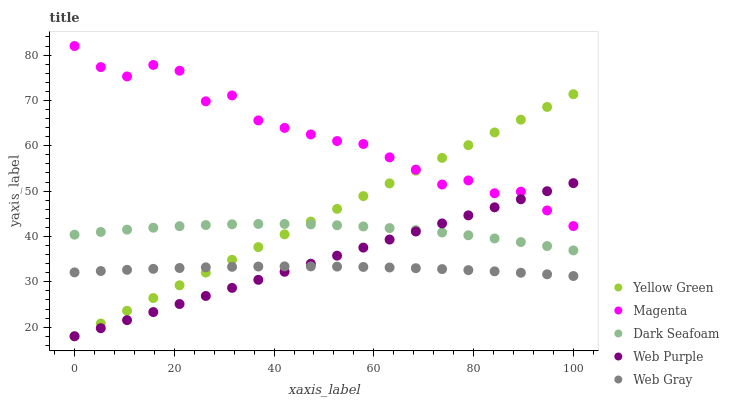Does Web Gray have the minimum area under the curve?
Answer yes or no. Yes. Does Magenta have the maximum area under the curve?
Answer yes or no. Yes. Does Magenta have the minimum area under the curve?
Answer yes or no. No. Does Web Gray have the maximum area under the curve?
Answer yes or no. No. Is Yellow Green the smoothest?
Answer yes or no. Yes. Is Magenta the roughest?
Answer yes or no. Yes. Is Web Gray the smoothest?
Answer yes or no. No. Is Web Gray the roughest?
Answer yes or no. No. Does Web Purple have the lowest value?
Answer yes or no. Yes. Does Web Gray have the lowest value?
Answer yes or no. No. Does Magenta have the highest value?
Answer yes or no. Yes. Does Web Gray have the highest value?
Answer yes or no. No. Is Web Gray less than Dark Seafoam?
Answer yes or no. Yes. Is Dark Seafoam greater than Web Gray?
Answer yes or no. Yes. Does Web Gray intersect Yellow Green?
Answer yes or no. Yes. Is Web Gray less than Yellow Green?
Answer yes or no. No. Is Web Gray greater than Yellow Green?
Answer yes or no. No. Does Web Gray intersect Dark Seafoam?
Answer yes or no. No. 